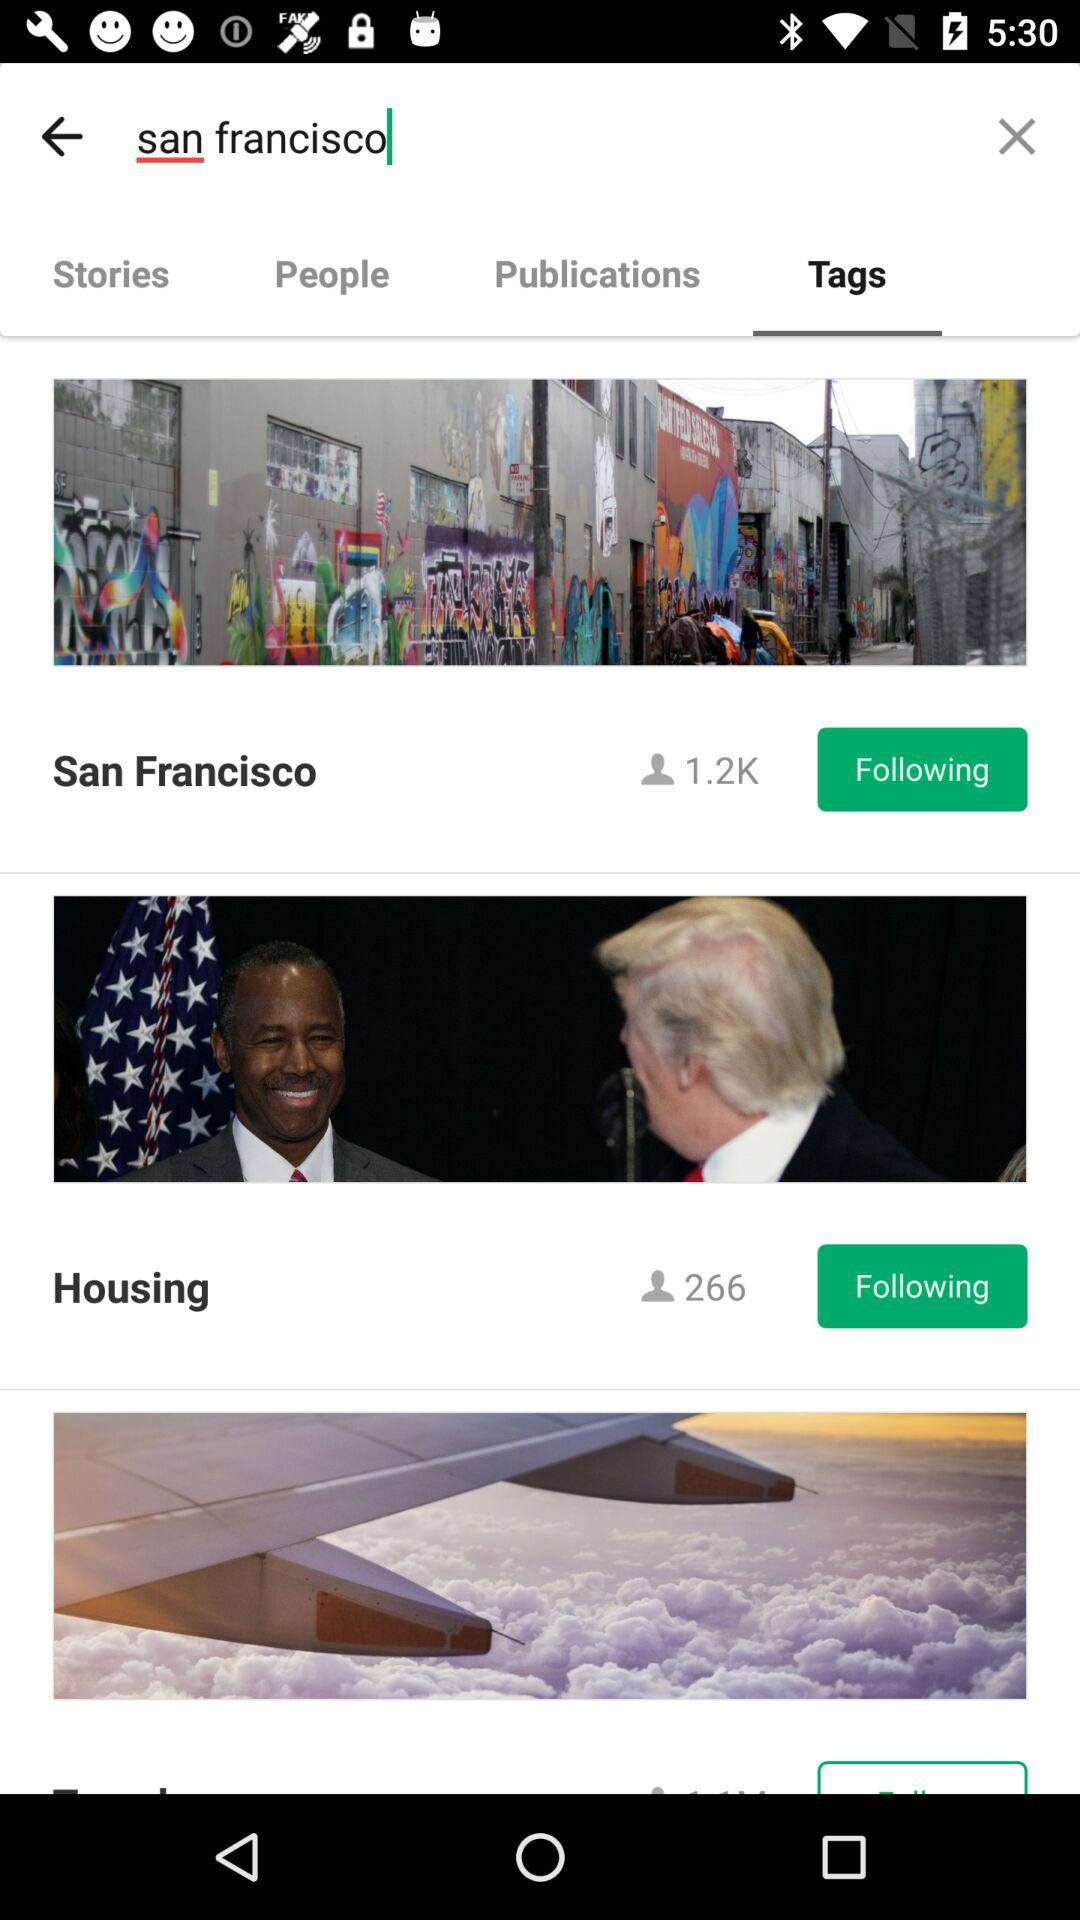What is the current location? The current location is San Francisco. 